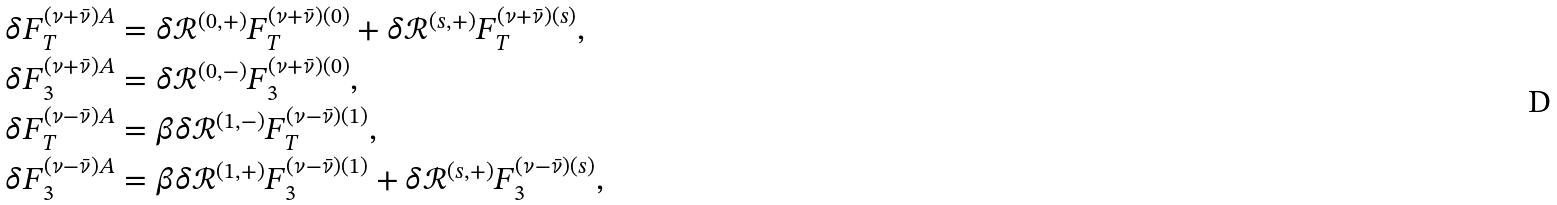<formula> <loc_0><loc_0><loc_500><loc_500>\delta F _ { T } ^ { ( \nu + \bar { \nu } ) A } & = \delta \mathcal { R } ^ { ( 0 , + ) } F _ { T } ^ { ( \nu + \bar { \nu } ) ( 0 ) } + \delta \mathcal { R } ^ { ( s , + ) } F _ { T } ^ { ( \nu + \bar { \nu } ) ( s ) } , \\ \delta F _ { 3 } ^ { ( \nu + \bar { \nu } ) A } & = \delta \mathcal { R } ^ { ( 0 , - ) } F _ { 3 } ^ { ( \nu + \bar { \nu } ) ( 0 ) } , \\ \delta F _ { T } ^ { ( \nu - \bar { \nu } ) A } & = \beta \delta \mathcal { R } ^ { ( 1 , - ) } F _ { T } ^ { ( \nu - \bar { \nu } ) ( 1 ) } , \\ \delta F _ { 3 } ^ { ( \nu - \bar { \nu } ) A } & = \beta \delta \mathcal { R } ^ { ( 1 , + ) } F _ { 3 } ^ { ( \nu - \bar { \nu } ) ( 1 ) } + \delta \mathcal { R } ^ { ( s , + ) } F _ { 3 } ^ { ( \nu - \bar { \nu } ) ( s ) } ,</formula> 